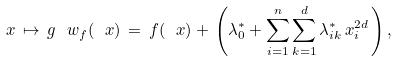Convert formula to latex. <formula><loc_0><loc_0><loc_500><loc_500>\ x \, \mapsto \, g ^ { \ } w _ { f } ( \ x ) \, = \, f ( \ x ) + \, \left ( \lambda ^ { * } _ { 0 } + \sum _ { i = 1 } ^ { n } \sum _ { k = 1 } ^ { d } \lambda ^ { * } _ { i k } \, x _ { i } ^ { 2 d } \, \right ) ,</formula> 